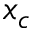Convert formula to latex. <formula><loc_0><loc_0><loc_500><loc_500>x _ { c }</formula> 